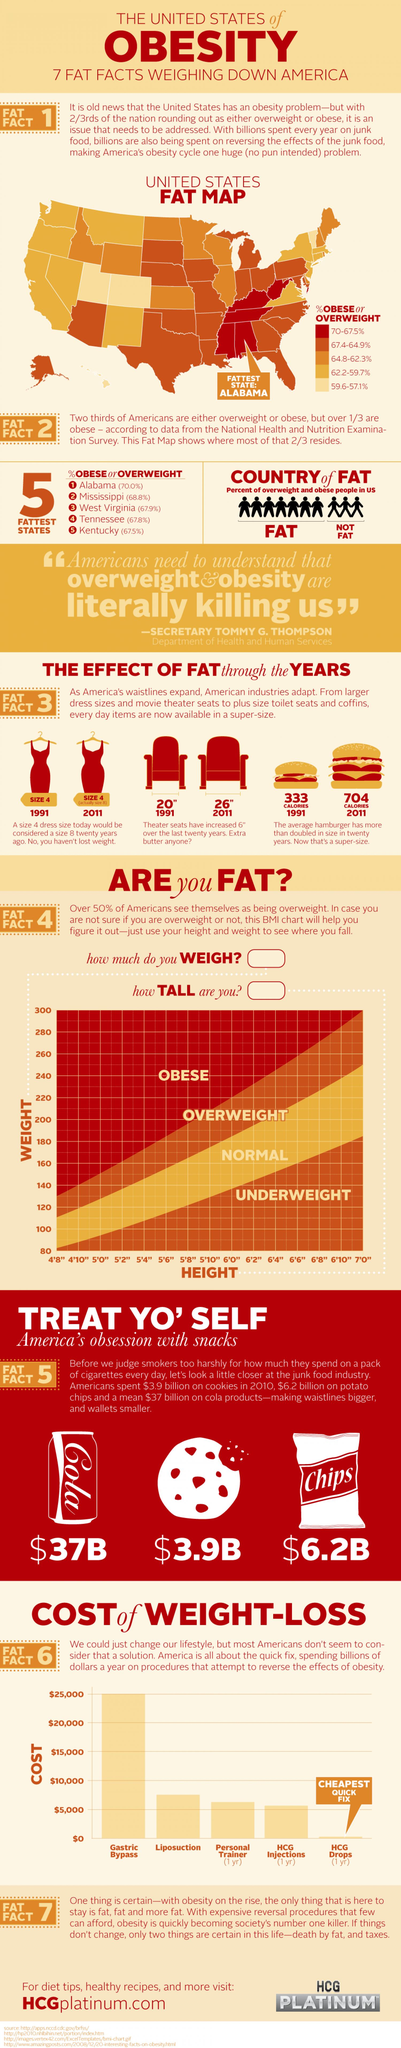Indicate a few pertinent items in this graphic. According to recent statistics, an alarming 68.8% of the population in the state of Mississippi is obese. This is a significant health concern that requires immediate attention and action. According to a study, the state with the least number of obese people in the United States is Kentucky. In West Virginia, 67.9% of the population is obese. In Alabama, approximately 30% of the population is not obese. Alabama is considered the fattest state in the United States. 